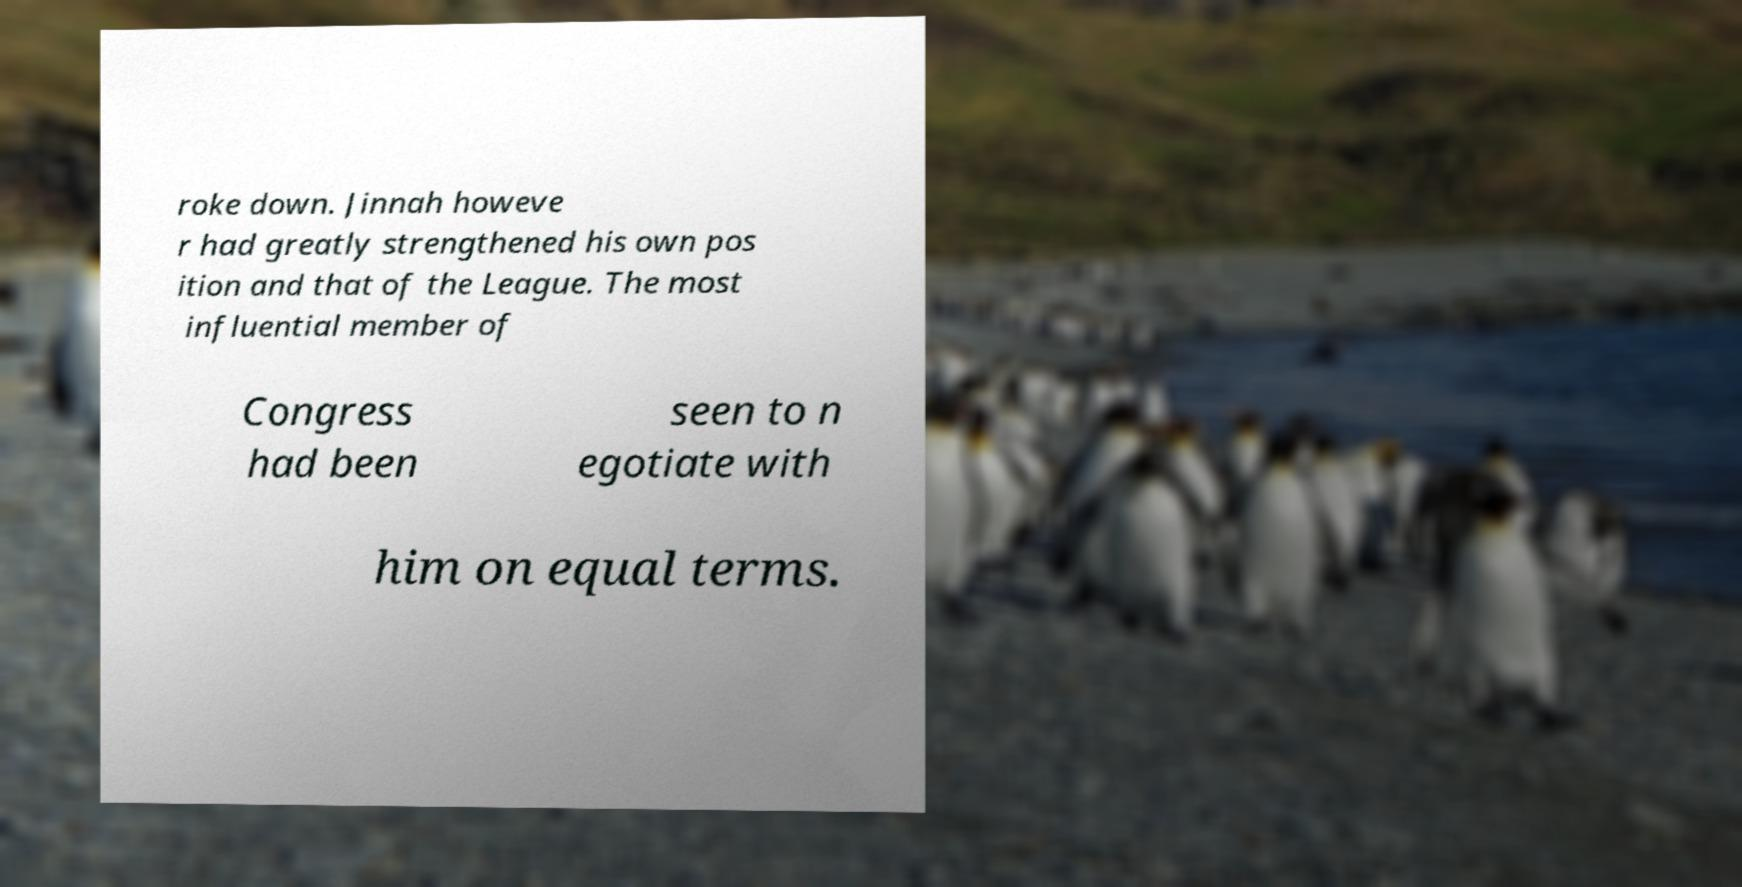Please read and relay the text visible in this image. What does it say? roke down. Jinnah howeve r had greatly strengthened his own pos ition and that of the League. The most influential member of Congress had been seen to n egotiate with him on equal terms. 